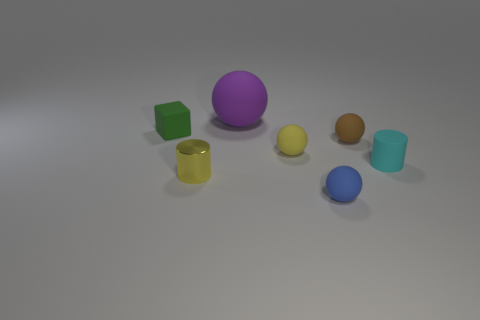What materials appear to be represented by these objects? The objects seem to exhibit various materials such as matte plastic, reflective metal, and maybe even rubber, given the soft light reflections and surface textures. 